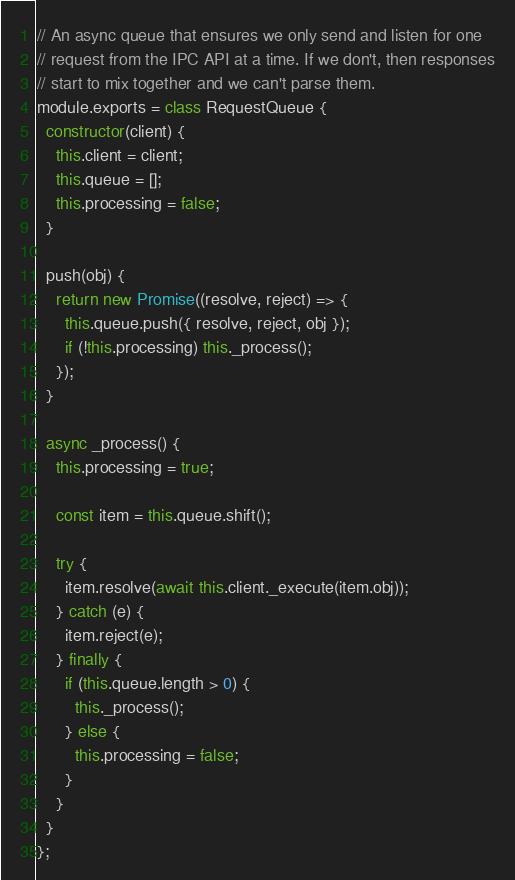Convert code to text. <code><loc_0><loc_0><loc_500><loc_500><_JavaScript_>// An async queue that ensures we only send and listen for one
// request from the IPC API at a time. If we don't, then responses
// start to mix together and we can't parse them.
module.exports = class RequestQueue {
  constructor(client) {
    this.client = client;
    this.queue = [];
    this.processing = false;
  }

  push(obj) {
    return new Promise((resolve, reject) => {
      this.queue.push({ resolve, reject, obj });
      if (!this.processing) this._process();
    });
  }

  async _process() {
    this.processing = true;

    const item = this.queue.shift();

    try {
      item.resolve(await this.client._execute(item.obj));
    } catch (e) {
      item.reject(e);
    } finally {
      if (this.queue.length > 0) {
        this._process();
      } else {
        this.processing = false;
      }
    }
  }
};
</code> 